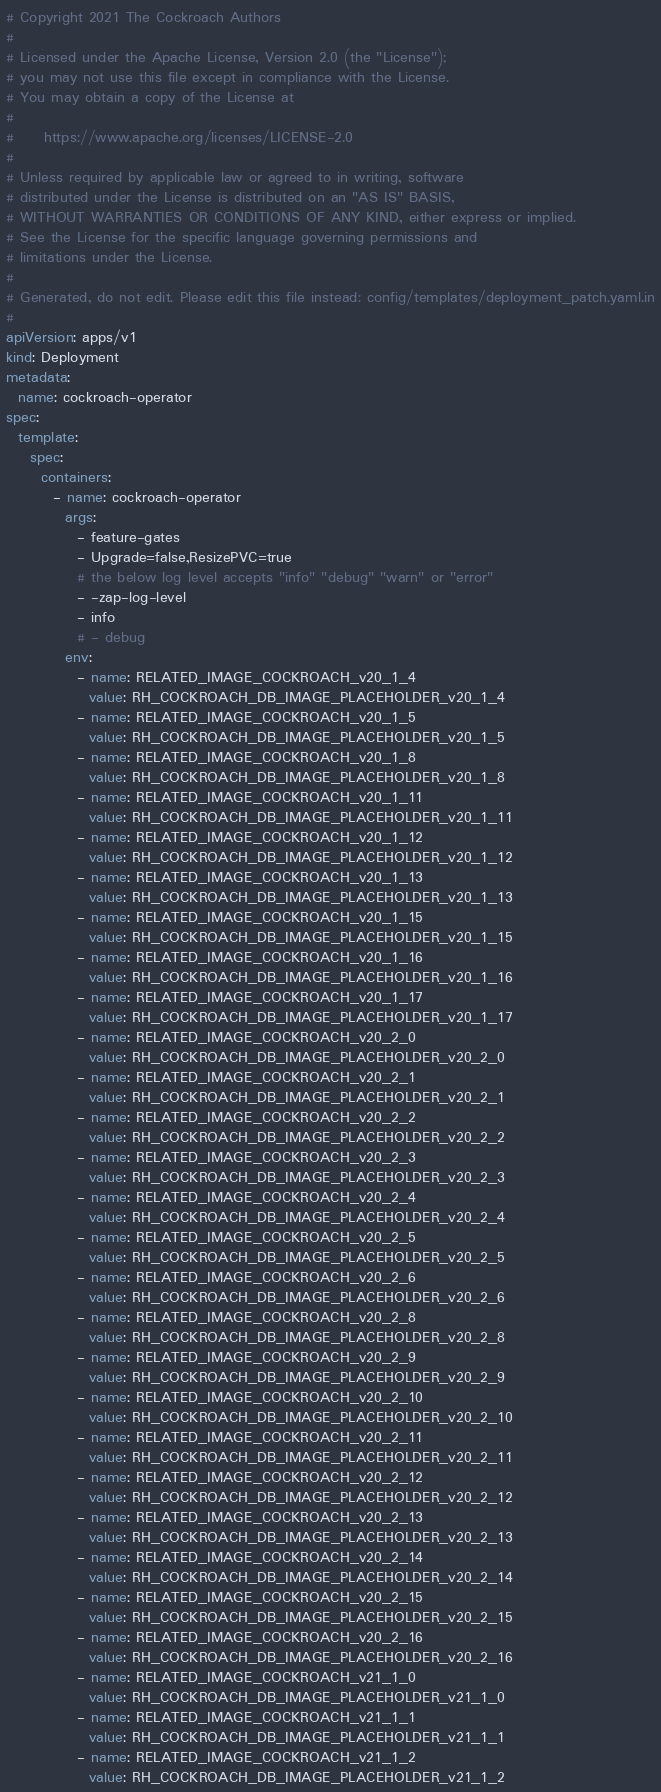<code> <loc_0><loc_0><loc_500><loc_500><_YAML_># Copyright 2021 The Cockroach Authors
#
# Licensed under the Apache License, Version 2.0 (the "License");
# you may not use this file except in compliance with the License.
# You may obtain a copy of the License at
#
#     https://www.apache.org/licenses/LICENSE-2.0
#
# Unless required by applicable law or agreed to in writing, software
# distributed under the License is distributed on an "AS IS" BASIS,
# WITHOUT WARRANTIES OR CONDITIONS OF ANY KIND, either express or implied.
# See the License for the specific language governing permissions and
# limitations under the License.
#
# Generated, do not edit. Please edit this file instead: config/templates/deployment_patch.yaml.in
#
apiVersion: apps/v1
kind: Deployment
metadata:
  name: cockroach-operator
spec:
  template:
    spec:
      containers:
        - name: cockroach-operator
          args:
            - feature-gates
            - Upgrade=false,ResizePVC=true
            # the below log level accepts "info" "debug" "warn" or "error"
            - -zap-log-level
            - info
            # - debug
          env:
            - name: RELATED_IMAGE_COCKROACH_v20_1_4
              value: RH_COCKROACH_DB_IMAGE_PLACEHOLDER_v20_1_4
            - name: RELATED_IMAGE_COCKROACH_v20_1_5
              value: RH_COCKROACH_DB_IMAGE_PLACEHOLDER_v20_1_5
            - name: RELATED_IMAGE_COCKROACH_v20_1_8
              value: RH_COCKROACH_DB_IMAGE_PLACEHOLDER_v20_1_8
            - name: RELATED_IMAGE_COCKROACH_v20_1_11
              value: RH_COCKROACH_DB_IMAGE_PLACEHOLDER_v20_1_11
            - name: RELATED_IMAGE_COCKROACH_v20_1_12
              value: RH_COCKROACH_DB_IMAGE_PLACEHOLDER_v20_1_12
            - name: RELATED_IMAGE_COCKROACH_v20_1_13
              value: RH_COCKROACH_DB_IMAGE_PLACEHOLDER_v20_1_13
            - name: RELATED_IMAGE_COCKROACH_v20_1_15
              value: RH_COCKROACH_DB_IMAGE_PLACEHOLDER_v20_1_15
            - name: RELATED_IMAGE_COCKROACH_v20_1_16
              value: RH_COCKROACH_DB_IMAGE_PLACEHOLDER_v20_1_16
            - name: RELATED_IMAGE_COCKROACH_v20_1_17
              value: RH_COCKROACH_DB_IMAGE_PLACEHOLDER_v20_1_17
            - name: RELATED_IMAGE_COCKROACH_v20_2_0
              value: RH_COCKROACH_DB_IMAGE_PLACEHOLDER_v20_2_0
            - name: RELATED_IMAGE_COCKROACH_v20_2_1
              value: RH_COCKROACH_DB_IMAGE_PLACEHOLDER_v20_2_1
            - name: RELATED_IMAGE_COCKROACH_v20_2_2
              value: RH_COCKROACH_DB_IMAGE_PLACEHOLDER_v20_2_2
            - name: RELATED_IMAGE_COCKROACH_v20_2_3
              value: RH_COCKROACH_DB_IMAGE_PLACEHOLDER_v20_2_3
            - name: RELATED_IMAGE_COCKROACH_v20_2_4
              value: RH_COCKROACH_DB_IMAGE_PLACEHOLDER_v20_2_4
            - name: RELATED_IMAGE_COCKROACH_v20_2_5
              value: RH_COCKROACH_DB_IMAGE_PLACEHOLDER_v20_2_5
            - name: RELATED_IMAGE_COCKROACH_v20_2_6
              value: RH_COCKROACH_DB_IMAGE_PLACEHOLDER_v20_2_6
            - name: RELATED_IMAGE_COCKROACH_v20_2_8
              value: RH_COCKROACH_DB_IMAGE_PLACEHOLDER_v20_2_8
            - name: RELATED_IMAGE_COCKROACH_v20_2_9
              value: RH_COCKROACH_DB_IMAGE_PLACEHOLDER_v20_2_9
            - name: RELATED_IMAGE_COCKROACH_v20_2_10
              value: RH_COCKROACH_DB_IMAGE_PLACEHOLDER_v20_2_10
            - name: RELATED_IMAGE_COCKROACH_v20_2_11
              value: RH_COCKROACH_DB_IMAGE_PLACEHOLDER_v20_2_11
            - name: RELATED_IMAGE_COCKROACH_v20_2_12
              value: RH_COCKROACH_DB_IMAGE_PLACEHOLDER_v20_2_12
            - name: RELATED_IMAGE_COCKROACH_v20_2_13
              value: RH_COCKROACH_DB_IMAGE_PLACEHOLDER_v20_2_13
            - name: RELATED_IMAGE_COCKROACH_v20_2_14
              value: RH_COCKROACH_DB_IMAGE_PLACEHOLDER_v20_2_14
            - name: RELATED_IMAGE_COCKROACH_v20_2_15
              value: RH_COCKROACH_DB_IMAGE_PLACEHOLDER_v20_2_15
            - name: RELATED_IMAGE_COCKROACH_v20_2_16
              value: RH_COCKROACH_DB_IMAGE_PLACEHOLDER_v20_2_16
            - name: RELATED_IMAGE_COCKROACH_v21_1_0
              value: RH_COCKROACH_DB_IMAGE_PLACEHOLDER_v21_1_0
            - name: RELATED_IMAGE_COCKROACH_v21_1_1
              value: RH_COCKROACH_DB_IMAGE_PLACEHOLDER_v21_1_1
            - name: RELATED_IMAGE_COCKROACH_v21_1_2
              value: RH_COCKROACH_DB_IMAGE_PLACEHOLDER_v21_1_2</code> 